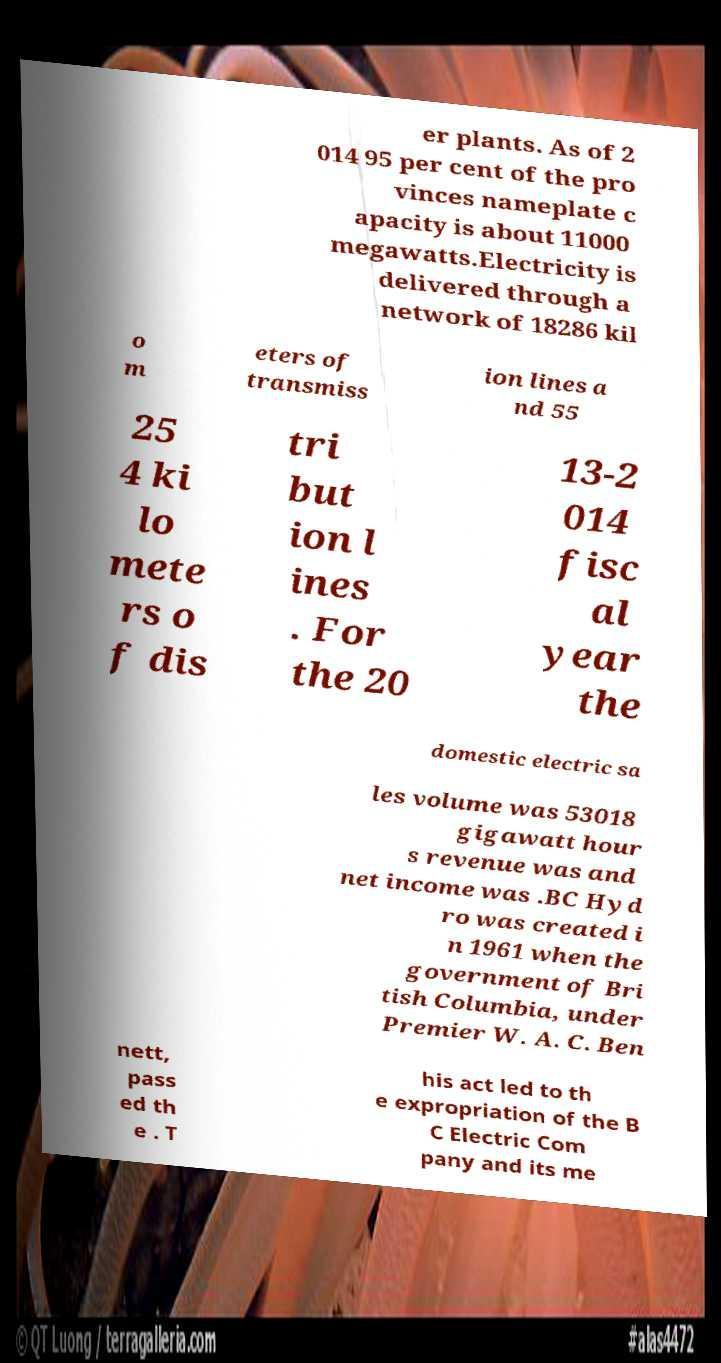What messages or text are displayed in this image? I need them in a readable, typed format. er plants. As of 2 014 95 per cent of the pro vinces nameplate c apacity is about 11000 megawatts.Electricity is delivered through a network of 18286 kil o m eters of transmiss ion lines a nd 55 25 4 ki lo mete rs o f dis tri but ion l ines . For the 20 13-2 014 fisc al year the domestic electric sa les volume was 53018 gigawatt hour s revenue was and net income was .BC Hyd ro was created i n 1961 when the government of Bri tish Columbia, under Premier W. A. C. Ben nett, pass ed th e . T his act led to th e expropriation of the B C Electric Com pany and its me 